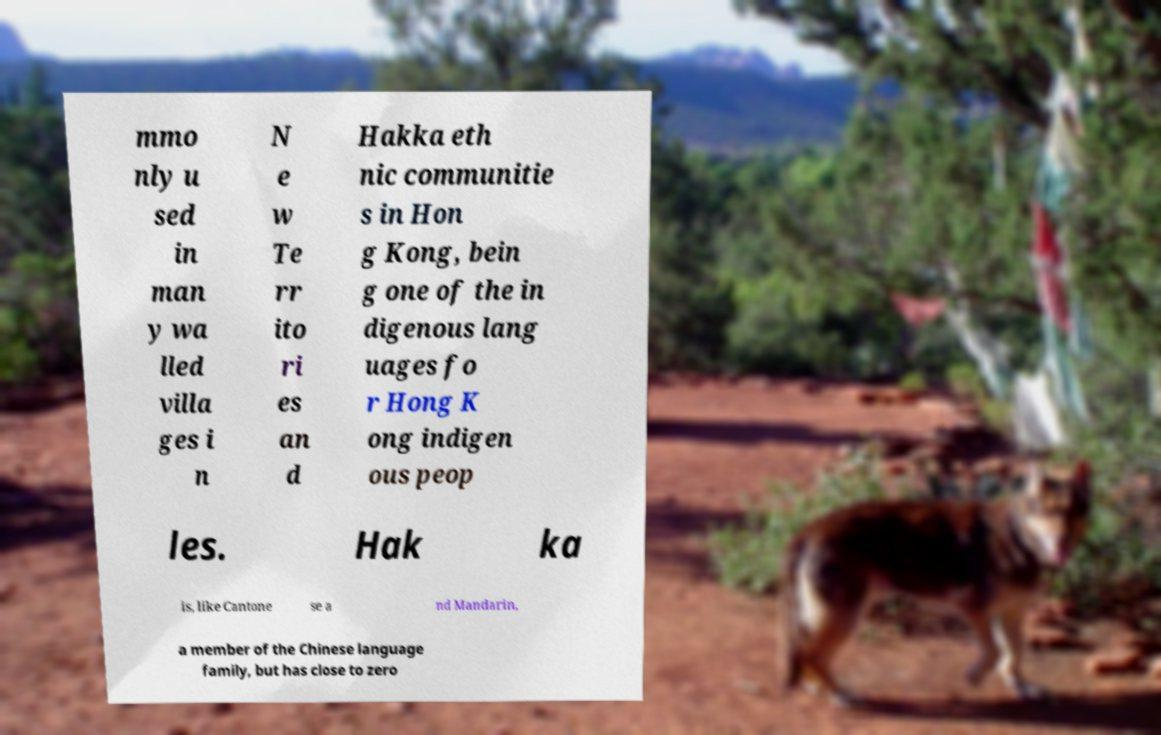Could you extract and type out the text from this image? mmo nly u sed in man y wa lled villa ges i n N e w Te rr ito ri es an d Hakka eth nic communitie s in Hon g Kong, bein g one of the in digenous lang uages fo r Hong K ong indigen ous peop les. Hak ka is, like Cantone se a nd Mandarin, a member of the Chinese language family, but has close to zero 